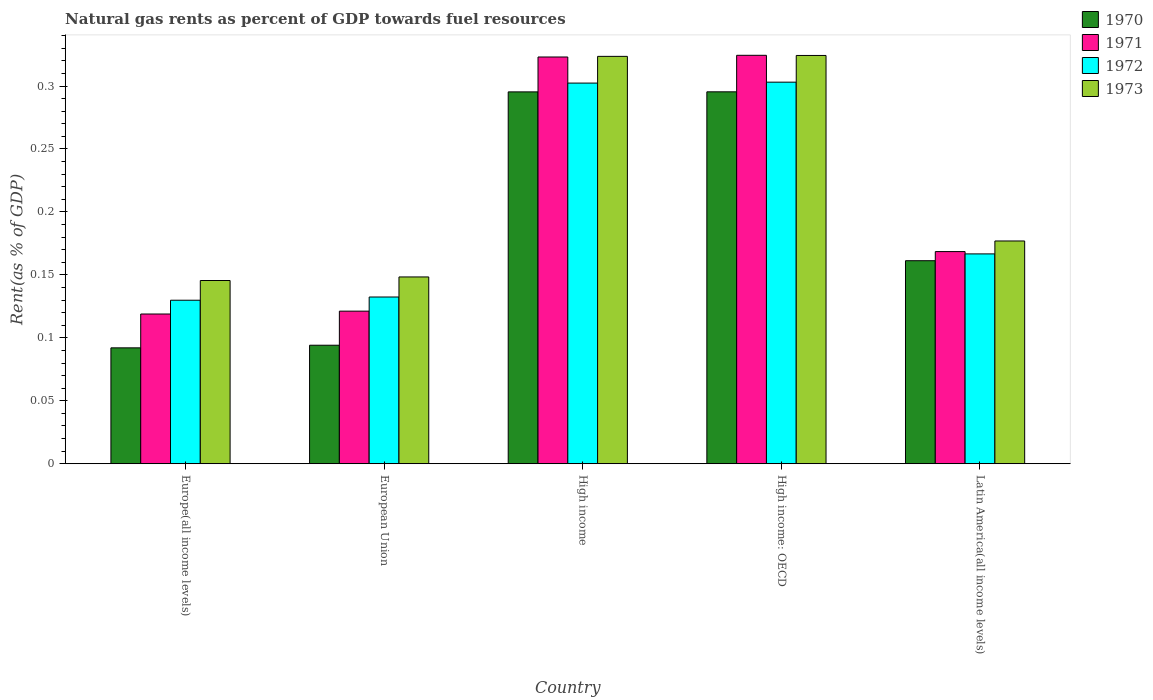How many different coloured bars are there?
Your answer should be very brief. 4. How many groups of bars are there?
Give a very brief answer. 5. Are the number of bars per tick equal to the number of legend labels?
Your answer should be compact. Yes. In how many cases, is the number of bars for a given country not equal to the number of legend labels?
Provide a short and direct response. 0. What is the matural gas rent in 1970 in Europe(all income levels)?
Provide a succinct answer. 0.09. Across all countries, what is the maximum matural gas rent in 1971?
Make the answer very short. 0.32. Across all countries, what is the minimum matural gas rent in 1970?
Make the answer very short. 0.09. In which country was the matural gas rent in 1970 maximum?
Offer a terse response. High income: OECD. In which country was the matural gas rent in 1970 minimum?
Offer a terse response. Europe(all income levels). What is the total matural gas rent in 1971 in the graph?
Ensure brevity in your answer.  1.06. What is the difference between the matural gas rent in 1973 in Europe(all income levels) and that in European Union?
Make the answer very short. -0. What is the difference between the matural gas rent in 1973 in European Union and the matural gas rent in 1970 in Europe(all income levels)?
Ensure brevity in your answer.  0.06. What is the average matural gas rent in 1972 per country?
Your answer should be very brief. 0.21. What is the difference between the matural gas rent of/in 1972 and matural gas rent of/in 1971 in European Union?
Keep it short and to the point. 0.01. In how many countries, is the matural gas rent in 1971 greater than 0.16000000000000003 %?
Give a very brief answer. 3. What is the ratio of the matural gas rent in 1970 in European Union to that in Latin America(all income levels)?
Give a very brief answer. 0.58. Is the matural gas rent in 1973 in European Union less than that in High income: OECD?
Your answer should be compact. Yes. What is the difference between the highest and the second highest matural gas rent in 1971?
Offer a terse response. 0. What is the difference between the highest and the lowest matural gas rent in 1971?
Provide a short and direct response. 0.21. In how many countries, is the matural gas rent in 1971 greater than the average matural gas rent in 1971 taken over all countries?
Offer a terse response. 2. Is it the case that in every country, the sum of the matural gas rent in 1973 and matural gas rent in 1971 is greater than the sum of matural gas rent in 1972 and matural gas rent in 1970?
Offer a terse response. No. What does the 2nd bar from the left in Europe(all income levels) represents?
Your response must be concise. 1971. Is it the case that in every country, the sum of the matural gas rent in 1973 and matural gas rent in 1971 is greater than the matural gas rent in 1972?
Your answer should be very brief. Yes. How many bars are there?
Your answer should be very brief. 20. Are all the bars in the graph horizontal?
Your answer should be very brief. No. How many countries are there in the graph?
Provide a short and direct response. 5. How many legend labels are there?
Your answer should be very brief. 4. How are the legend labels stacked?
Provide a short and direct response. Vertical. What is the title of the graph?
Your answer should be compact. Natural gas rents as percent of GDP towards fuel resources. What is the label or title of the Y-axis?
Keep it short and to the point. Rent(as % of GDP). What is the Rent(as % of GDP) in 1970 in Europe(all income levels)?
Your answer should be very brief. 0.09. What is the Rent(as % of GDP) of 1971 in Europe(all income levels)?
Your answer should be compact. 0.12. What is the Rent(as % of GDP) of 1972 in Europe(all income levels)?
Ensure brevity in your answer.  0.13. What is the Rent(as % of GDP) of 1973 in Europe(all income levels)?
Ensure brevity in your answer.  0.15. What is the Rent(as % of GDP) of 1970 in European Union?
Offer a very short reply. 0.09. What is the Rent(as % of GDP) in 1971 in European Union?
Give a very brief answer. 0.12. What is the Rent(as % of GDP) in 1972 in European Union?
Offer a terse response. 0.13. What is the Rent(as % of GDP) of 1973 in European Union?
Make the answer very short. 0.15. What is the Rent(as % of GDP) of 1970 in High income?
Your response must be concise. 0.3. What is the Rent(as % of GDP) in 1971 in High income?
Offer a terse response. 0.32. What is the Rent(as % of GDP) of 1972 in High income?
Provide a succinct answer. 0.3. What is the Rent(as % of GDP) of 1973 in High income?
Offer a terse response. 0.32. What is the Rent(as % of GDP) in 1970 in High income: OECD?
Provide a succinct answer. 0.3. What is the Rent(as % of GDP) in 1971 in High income: OECD?
Make the answer very short. 0.32. What is the Rent(as % of GDP) in 1972 in High income: OECD?
Keep it short and to the point. 0.3. What is the Rent(as % of GDP) in 1973 in High income: OECD?
Keep it short and to the point. 0.32. What is the Rent(as % of GDP) of 1970 in Latin America(all income levels)?
Offer a very short reply. 0.16. What is the Rent(as % of GDP) of 1971 in Latin America(all income levels)?
Your response must be concise. 0.17. What is the Rent(as % of GDP) of 1972 in Latin America(all income levels)?
Offer a terse response. 0.17. What is the Rent(as % of GDP) in 1973 in Latin America(all income levels)?
Give a very brief answer. 0.18. Across all countries, what is the maximum Rent(as % of GDP) of 1970?
Offer a terse response. 0.3. Across all countries, what is the maximum Rent(as % of GDP) of 1971?
Ensure brevity in your answer.  0.32. Across all countries, what is the maximum Rent(as % of GDP) in 1972?
Your response must be concise. 0.3. Across all countries, what is the maximum Rent(as % of GDP) in 1973?
Your answer should be very brief. 0.32. Across all countries, what is the minimum Rent(as % of GDP) in 1970?
Provide a succinct answer. 0.09. Across all countries, what is the minimum Rent(as % of GDP) in 1971?
Your response must be concise. 0.12. Across all countries, what is the minimum Rent(as % of GDP) in 1972?
Your answer should be very brief. 0.13. Across all countries, what is the minimum Rent(as % of GDP) in 1973?
Offer a terse response. 0.15. What is the total Rent(as % of GDP) in 1970 in the graph?
Offer a terse response. 0.94. What is the total Rent(as % of GDP) of 1971 in the graph?
Provide a short and direct response. 1.06. What is the total Rent(as % of GDP) in 1972 in the graph?
Ensure brevity in your answer.  1.03. What is the total Rent(as % of GDP) in 1973 in the graph?
Ensure brevity in your answer.  1.12. What is the difference between the Rent(as % of GDP) of 1970 in Europe(all income levels) and that in European Union?
Ensure brevity in your answer.  -0. What is the difference between the Rent(as % of GDP) in 1971 in Europe(all income levels) and that in European Union?
Provide a short and direct response. -0. What is the difference between the Rent(as % of GDP) in 1972 in Europe(all income levels) and that in European Union?
Give a very brief answer. -0. What is the difference between the Rent(as % of GDP) of 1973 in Europe(all income levels) and that in European Union?
Provide a short and direct response. -0. What is the difference between the Rent(as % of GDP) of 1970 in Europe(all income levels) and that in High income?
Keep it short and to the point. -0.2. What is the difference between the Rent(as % of GDP) in 1971 in Europe(all income levels) and that in High income?
Make the answer very short. -0.2. What is the difference between the Rent(as % of GDP) in 1972 in Europe(all income levels) and that in High income?
Make the answer very short. -0.17. What is the difference between the Rent(as % of GDP) of 1973 in Europe(all income levels) and that in High income?
Your answer should be compact. -0.18. What is the difference between the Rent(as % of GDP) in 1970 in Europe(all income levels) and that in High income: OECD?
Provide a short and direct response. -0.2. What is the difference between the Rent(as % of GDP) of 1971 in Europe(all income levels) and that in High income: OECD?
Ensure brevity in your answer.  -0.21. What is the difference between the Rent(as % of GDP) of 1972 in Europe(all income levels) and that in High income: OECD?
Ensure brevity in your answer.  -0.17. What is the difference between the Rent(as % of GDP) in 1973 in Europe(all income levels) and that in High income: OECD?
Give a very brief answer. -0.18. What is the difference between the Rent(as % of GDP) of 1970 in Europe(all income levels) and that in Latin America(all income levels)?
Your answer should be very brief. -0.07. What is the difference between the Rent(as % of GDP) of 1971 in Europe(all income levels) and that in Latin America(all income levels)?
Ensure brevity in your answer.  -0.05. What is the difference between the Rent(as % of GDP) in 1972 in Europe(all income levels) and that in Latin America(all income levels)?
Your response must be concise. -0.04. What is the difference between the Rent(as % of GDP) in 1973 in Europe(all income levels) and that in Latin America(all income levels)?
Offer a very short reply. -0.03. What is the difference between the Rent(as % of GDP) of 1970 in European Union and that in High income?
Give a very brief answer. -0.2. What is the difference between the Rent(as % of GDP) of 1971 in European Union and that in High income?
Ensure brevity in your answer.  -0.2. What is the difference between the Rent(as % of GDP) of 1972 in European Union and that in High income?
Provide a short and direct response. -0.17. What is the difference between the Rent(as % of GDP) in 1973 in European Union and that in High income?
Offer a terse response. -0.18. What is the difference between the Rent(as % of GDP) in 1970 in European Union and that in High income: OECD?
Offer a very short reply. -0.2. What is the difference between the Rent(as % of GDP) of 1971 in European Union and that in High income: OECD?
Keep it short and to the point. -0.2. What is the difference between the Rent(as % of GDP) in 1972 in European Union and that in High income: OECD?
Make the answer very short. -0.17. What is the difference between the Rent(as % of GDP) of 1973 in European Union and that in High income: OECD?
Keep it short and to the point. -0.18. What is the difference between the Rent(as % of GDP) of 1970 in European Union and that in Latin America(all income levels)?
Your response must be concise. -0.07. What is the difference between the Rent(as % of GDP) in 1971 in European Union and that in Latin America(all income levels)?
Provide a short and direct response. -0.05. What is the difference between the Rent(as % of GDP) of 1972 in European Union and that in Latin America(all income levels)?
Offer a very short reply. -0.03. What is the difference between the Rent(as % of GDP) of 1973 in European Union and that in Latin America(all income levels)?
Provide a succinct answer. -0.03. What is the difference between the Rent(as % of GDP) in 1970 in High income and that in High income: OECD?
Make the answer very short. -0. What is the difference between the Rent(as % of GDP) in 1971 in High income and that in High income: OECD?
Your response must be concise. -0. What is the difference between the Rent(as % of GDP) in 1972 in High income and that in High income: OECD?
Your answer should be very brief. -0. What is the difference between the Rent(as % of GDP) in 1973 in High income and that in High income: OECD?
Your response must be concise. -0. What is the difference between the Rent(as % of GDP) in 1970 in High income and that in Latin America(all income levels)?
Provide a succinct answer. 0.13. What is the difference between the Rent(as % of GDP) of 1971 in High income and that in Latin America(all income levels)?
Keep it short and to the point. 0.15. What is the difference between the Rent(as % of GDP) in 1972 in High income and that in Latin America(all income levels)?
Give a very brief answer. 0.14. What is the difference between the Rent(as % of GDP) in 1973 in High income and that in Latin America(all income levels)?
Provide a succinct answer. 0.15. What is the difference between the Rent(as % of GDP) in 1970 in High income: OECD and that in Latin America(all income levels)?
Your answer should be compact. 0.13. What is the difference between the Rent(as % of GDP) in 1971 in High income: OECD and that in Latin America(all income levels)?
Offer a very short reply. 0.16. What is the difference between the Rent(as % of GDP) of 1972 in High income: OECD and that in Latin America(all income levels)?
Provide a short and direct response. 0.14. What is the difference between the Rent(as % of GDP) of 1973 in High income: OECD and that in Latin America(all income levels)?
Ensure brevity in your answer.  0.15. What is the difference between the Rent(as % of GDP) in 1970 in Europe(all income levels) and the Rent(as % of GDP) in 1971 in European Union?
Make the answer very short. -0.03. What is the difference between the Rent(as % of GDP) in 1970 in Europe(all income levels) and the Rent(as % of GDP) in 1972 in European Union?
Give a very brief answer. -0.04. What is the difference between the Rent(as % of GDP) in 1970 in Europe(all income levels) and the Rent(as % of GDP) in 1973 in European Union?
Ensure brevity in your answer.  -0.06. What is the difference between the Rent(as % of GDP) in 1971 in Europe(all income levels) and the Rent(as % of GDP) in 1972 in European Union?
Give a very brief answer. -0.01. What is the difference between the Rent(as % of GDP) in 1971 in Europe(all income levels) and the Rent(as % of GDP) in 1973 in European Union?
Your answer should be very brief. -0.03. What is the difference between the Rent(as % of GDP) in 1972 in Europe(all income levels) and the Rent(as % of GDP) in 1973 in European Union?
Your answer should be very brief. -0.02. What is the difference between the Rent(as % of GDP) of 1970 in Europe(all income levels) and the Rent(as % of GDP) of 1971 in High income?
Make the answer very short. -0.23. What is the difference between the Rent(as % of GDP) of 1970 in Europe(all income levels) and the Rent(as % of GDP) of 1972 in High income?
Ensure brevity in your answer.  -0.21. What is the difference between the Rent(as % of GDP) of 1970 in Europe(all income levels) and the Rent(as % of GDP) of 1973 in High income?
Your answer should be very brief. -0.23. What is the difference between the Rent(as % of GDP) of 1971 in Europe(all income levels) and the Rent(as % of GDP) of 1972 in High income?
Offer a very short reply. -0.18. What is the difference between the Rent(as % of GDP) in 1971 in Europe(all income levels) and the Rent(as % of GDP) in 1973 in High income?
Ensure brevity in your answer.  -0.2. What is the difference between the Rent(as % of GDP) in 1972 in Europe(all income levels) and the Rent(as % of GDP) in 1973 in High income?
Offer a very short reply. -0.19. What is the difference between the Rent(as % of GDP) of 1970 in Europe(all income levels) and the Rent(as % of GDP) of 1971 in High income: OECD?
Make the answer very short. -0.23. What is the difference between the Rent(as % of GDP) of 1970 in Europe(all income levels) and the Rent(as % of GDP) of 1972 in High income: OECD?
Your response must be concise. -0.21. What is the difference between the Rent(as % of GDP) in 1970 in Europe(all income levels) and the Rent(as % of GDP) in 1973 in High income: OECD?
Keep it short and to the point. -0.23. What is the difference between the Rent(as % of GDP) of 1971 in Europe(all income levels) and the Rent(as % of GDP) of 1972 in High income: OECD?
Provide a succinct answer. -0.18. What is the difference between the Rent(as % of GDP) of 1971 in Europe(all income levels) and the Rent(as % of GDP) of 1973 in High income: OECD?
Provide a short and direct response. -0.21. What is the difference between the Rent(as % of GDP) of 1972 in Europe(all income levels) and the Rent(as % of GDP) of 1973 in High income: OECD?
Ensure brevity in your answer.  -0.19. What is the difference between the Rent(as % of GDP) of 1970 in Europe(all income levels) and the Rent(as % of GDP) of 1971 in Latin America(all income levels)?
Make the answer very short. -0.08. What is the difference between the Rent(as % of GDP) of 1970 in Europe(all income levels) and the Rent(as % of GDP) of 1972 in Latin America(all income levels)?
Your answer should be very brief. -0.07. What is the difference between the Rent(as % of GDP) in 1970 in Europe(all income levels) and the Rent(as % of GDP) in 1973 in Latin America(all income levels)?
Offer a very short reply. -0.08. What is the difference between the Rent(as % of GDP) in 1971 in Europe(all income levels) and the Rent(as % of GDP) in 1972 in Latin America(all income levels)?
Offer a very short reply. -0.05. What is the difference between the Rent(as % of GDP) of 1971 in Europe(all income levels) and the Rent(as % of GDP) of 1973 in Latin America(all income levels)?
Your answer should be very brief. -0.06. What is the difference between the Rent(as % of GDP) in 1972 in Europe(all income levels) and the Rent(as % of GDP) in 1973 in Latin America(all income levels)?
Ensure brevity in your answer.  -0.05. What is the difference between the Rent(as % of GDP) in 1970 in European Union and the Rent(as % of GDP) in 1971 in High income?
Provide a succinct answer. -0.23. What is the difference between the Rent(as % of GDP) of 1970 in European Union and the Rent(as % of GDP) of 1972 in High income?
Keep it short and to the point. -0.21. What is the difference between the Rent(as % of GDP) of 1970 in European Union and the Rent(as % of GDP) of 1973 in High income?
Your response must be concise. -0.23. What is the difference between the Rent(as % of GDP) in 1971 in European Union and the Rent(as % of GDP) in 1972 in High income?
Make the answer very short. -0.18. What is the difference between the Rent(as % of GDP) of 1971 in European Union and the Rent(as % of GDP) of 1973 in High income?
Offer a terse response. -0.2. What is the difference between the Rent(as % of GDP) of 1972 in European Union and the Rent(as % of GDP) of 1973 in High income?
Offer a very short reply. -0.19. What is the difference between the Rent(as % of GDP) of 1970 in European Union and the Rent(as % of GDP) of 1971 in High income: OECD?
Provide a short and direct response. -0.23. What is the difference between the Rent(as % of GDP) in 1970 in European Union and the Rent(as % of GDP) in 1972 in High income: OECD?
Offer a terse response. -0.21. What is the difference between the Rent(as % of GDP) of 1970 in European Union and the Rent(as % of GDP) of 1973 in High income: OECD?
Your answer should be very brief. -0.23. What is the difference between the Rent(as % of GDP) of 1971 in European Union and the Rent(as % of GDP) of 1972 in High income: OECD?
Ensure brevity in your answer.  -0.18. What is the difference between the Rent(as % of GDP) in 1971 in European Union and the Rent(as % of GDP) in 1973 in High income: OECD?
Keep it short and to the point. -0.2. What is the difference between the Rent(as % of GDP) in 1972 in European Union and the Rent(as % of GDP) in 1973 in High income: OECD?
Offer a very short reply. -0.19. What is the difference between the Rent(as % of GDP) of 1970 in European Union and the Rent(as % of GDP) of 1971 in Latin America(all income levels)?
Your answer should be compact. -0.07. What is the difference between the Rent(as % of GDP) in 1970 in European Union and the Rent(as % of GDP) in 1972 in Latin America(all income levels)?
Provide a succinct answer. -0.07. What is the difference between the Rent(as % of GDP) of 1970 in European Union and the Rent(as % of GDP) of 1973 in Latin America(all income levels)?
Ensure brevity in your answer.  -0.08. What is the difference between the Rent(as % of GDP) in 1971 in European Union and the Rent(as % of GDP) in 1972 in Latin America(all income levels)?
Make the answer very short. -0.05. What is the difference between the Rent(as % of GDP) in 1971 in European Union and the Rent(as % of GDP) in 1973 in Latin America(all income levels)?
Give a very brief answer. -0.06. What is the difference between the Rent(as % of GDP) in 1972 in European Union and the Rent(as % of GDP) in 1973 in Latin America(all income levels)?
Provide a short and direct response. -0.04. What is the difference between the Rent(as % of GDP) of 1970 in High income and the Rent(as % of GDP) of 1971 in High income: OECD?
Offer a terse response. -0.03. What is the difference between the Rent(as % of GDP) in 1970 in High income and the Rent(as % of GDP) in 1972 in High income: OECD?
Your response must be concise. -0.01. What is the difference between the Rent(as % of GDP) in 1970 in High income and the Rent(as % of GDP) in 1973 in High income: OECD?
Your answer should be compact. -0.03. What is the difference between the Rent(as % of GDP) of 1971 in High income and the Rent(as % of GDP) of 1973 in High income: OECD?
Give a very brief answer. -0. What is the difference between the Rent(as % of GDP) in 1972 in High income and the Rent(as % of GDP) in 1973 in High income: OECD?
Make the answer very short. -0.02. What is the difference between the Rent(as % of GDP) in 1970 in High income and the Rent(as % of GDP) in 1971 in Latin America(all income levels)?
Provide a succinct answer. 0.13. What is the difference between the Rent(as % of GDP) of 1970 in High income and the Rent(as % of GDP) of 1972 in Latin America(all income levels)?
Offer a very short reply. 0.13. What is the difference between the Rent(as % of GDP) of 1970 in High income and the Rent(as % of GDP) of 1973 in Latin America(all income levels)?
Keep it short and to the point. 0.12. What is the difference between the Rent(as % of GDP) in 1971 in High income and the Rent(as % of GDP) in 1972 in Latin America(all income levels)?
Your answer should be compact. 0.16. What is the difference between the Rent(as % of GDP) in 1971 in High income and the Rent(as % of GDP) in 1973 in Latin America(all income levels)?
Give a very brief answer. 0.15. What is the difference between the Rent(as % of GDP) of 1972 in High income and the Rent(as % of GDP) of 1973 in Latin America(all income levels)?
Your answer should be compact. 0.13. What is the difference between the Rent(as % of GDP) in 1970 in High income: OECD and the Rent(as % of GDP) in 1971 in Latin America(all income levels)?
Your answer should be compact. 0.13. What is the difference between the Rent(as % of GDP) in 1970 in High income: OECD and the Rent(as % of GDP) in 1972 in Latin America(all income levels)?
Keep it short and to the point. 0.13. What is the difference between the Rent(as % of GDP) in 1970 in High income: OECD and the Rent(as % of GDP) in 1973 in Latin America(all income levels)?
Provide a succinct answer. 0.12. What is the difference between the Rent(as % of GDP) in 1971 in High income: OECD and the Rent(as % of GDP) in 1972 in Latin America(all income levels)?
Your answer should be very brief. 0.16. What is the difference between the Rent(as % of GDP) of 1971 in High income: OECD and the Rent(as % of GDP) of 1973 in Latin America(all income levels)?
Provide a short and direct response. 0.15. What is the difference between the Rent(as % of GDP) of 1972 in High income: OECD and the Rent(as % of GDP) of 1973 in Latin America(all income levels)?
Offer a very short reply. 0.13. What is the average Rent(as % of GDP) of 1970 per country?
Offer a very short reply. 0.19. What is the average Rent(as % of GDP) of 1971 per country?
Give a very brief answer. 0.21. What is the average Rent(as % of GDP) of 1972 per country?
Make the answer very short. 0.21. What is the average Rent(as % of GDP) in 1973 per country?
Make the answer very short. 0.22. What is the difference between the Rent(as % of GDP) of 1970 and Rent(as % of GDP) of 1971 in Europe(all income levels)?
Keep it short and to the point. -0.03. What is the difference between the Rent(as % of GDP) in 1970 and Rent(as % of GDP) in 1972 in Europe(all income levels)?
Offer a very short reply. -0.04. What is the difference between the Rent(as % of GDP) of 1970 and Rent(as % of GDP) of 1973 in Europe(all income levels)?
Offer a terse response. -0.05. What is the difference between the Rent(as % of GDP) of 1971 and Rent(as % of GDP) of 1972 in Europe(all income levels)?
Your answer should be very brief. -0.01. What is the difference between the Rent(as % of GDP) in 1971 and Rent(as % of GDP) in 1973 in Europe(all income levels)?
Provide a succinct answer. -0.03. What is the difference between the Rent(as % of GDP) in 1972 and Rent(as % of GDP) in 1973 in Europe(all income levels)?
Provide a succinct answer. -0.02. What is the difference between the Rent(as % of GDP) in 1970 and Rent(as % of GDP) in 1971 in European Union?
Your answer should be very brief. -0.03. What is the difference between the Rent(as % of GDP) in 1970 and Rent(as % of GDP) in 1972 in European Union?
Your answer should be compact. -0.04. What is the difference between the Rent(as % of GDP) of 1970 and Rent(as % of GDP) of 1973 in European Union?
Provide a short and direct response. -0.05. What is the difference between the Rent(as % of GDP) of 1971 and Rent(as % of GDP) of 1972 in European Union?
Provide a short and direct response. -0.01. What is the difference between the Rent(as % of GDP) of 1971 and Rent(as % of GDP) of 1973 in European Union?
Ensure brevity in your answer.  -0.03. What is the difference between the Rent(as % of GDP) in 1972 and Rent(as % of GDP) in 1973 in European Union?
Offer a terse response. -0.02. What is the difference between the Rent(as % of GDP) of 1970 and Rent(as % of GDP) of 1971 in High income?
Your answer should be compact. -0.03. What is the difference between the Rent(as % of GDP) of 1970 and Rent(as % of GDP) of 1972 in High income?
Your answer should be compact. -0.01. What is the difference between the Rent(as % of GDP) of 1970 and Rent(as % of GDP) of 1973 in High income?
Keep it short and to the point. -0.03. What is the difference between the Rent(as % of GDP) in 1971 and Rent(as % of GDP) in 1972 in High income?
Provide a short and direct response. 0.02. What is the difference between the Rent(as % of GDP) of 1971 and Rent(as % of GDP) of 1973 in High income?
Provide a short and direct response. -0. What is the difference between the Rent(as % of GDP) of 1972 and Rent(as % of GDP) of 1973 in High income?
Make the answer very short. -0.02. What is the difference between the Rent(as % of GDP) in 1970 and Rent(as % of GDP) in 1971 in High income: OECD?
Keep it short and to the point. -0.03. What is the difference between the Rent(as % of GDP) in 1970 and Rent(as % of GDP) in 1972 in High income: OECD?
Your answer should be compact. -0.01. What is the difference between the Rent(as % of GDP) of 1970 and Rent(as % of GDP) of 1973 in High income: OECD?
Your answer should be very brief. -0.03. What is the difference between the Rent(as % of GDP) in 1971 and Rent(as % of GDP) in 1972 in High income: OECD?
Offer a very short reply. 0.02. What is the difference between the Rent(as % of GDP) of 1972 and Rent(as % of GDP) of 1973 in High income: OECD?
Offer a very short reply. -0.02. What is the difference between the Rent(as % of GDP) of 1970 and Rent(as % of GDP) of 1971 in Latin America(all income levels)?
Provide a succinct answer. -0.01. What is the difference between the Rent(as % of GDP) in 1970 and Rent(as % of GDP) in 1972 in Latin America(all income levels)?
Offer a very short reply. -0.01. What is the difference between the Rent(as % of GDP) in 1970 and Rent(as % of GDP) in 1973 in Latin America(all income levels)?
Give a very brief answer. -0.02. What is the difference between the Rent(as % of GDP) in 1971 and Rent(as % of GDP) in 1972 in Latin America(all income levels)?
Make the answer very short. 0. What is the difference between the Rent(as % of GDP) in 1971 and Rent(as % of GDP) in 1973 in Latin America(all income levels)?
Give a very brief answer. -0.01. What is the difference between the Rent(as % of GDP) of 1972 and Rent(as % of GDP) of 1973 in Latin America(all income levels)?
Make the answer very short. -0.01. What is the ratio of the Rent(as % of GDP) of 1970 in Europe(all income levels) to that in European Union?
Ensure brevity in your answer.  0.98. What is the ratio of the Rent(as % of GDP) in 1971 in Europe(all income levels) to that in European Union?
Your answer should be compact. 0.98. What is the ratio of the Rent(as % of GDP) in 1972 in Europe(all income levels) to that in European Union?
Ensure brevity in your answer.  0.98. What is the ratio of the Rent(as % of GDP) of 1973 in Europe(all income levels) to that in European Union?
Provide a short and direct response. 0.98. What is the ratio of the Rent(as % of GDP) in 1970 in Europe(all income levels) to that in High income?
Your answer should be compact. 0.31. What is the ratio of the Rent(as % of GDP) in 1971 in Europe(all income levels) to that in High income?
Your answer should be very brief. 0.37. What is the ratio of the Rent(as % of GDP) of 1972 in Europe(all income levels) to that in High income?
Provide a short and direct response. 0.43. What is the ratio of the Rent(as % of GDP) of 1973 in Europe(all income levels) to that in High income?
Give a very brief answer. 0.45. What is the ratio of the Rent(as % of GDP) in 1970 in Europe(all income levels) to that in High income: OECD?
Your answer should be very brief. 0.31. What is the ratio of the Rent(as % of GDP) of 1971 in Europe(all income levels) to that in High income: OECD?
Ensure brevity in your answer.  0.37. What is the ratio of the Rent(as % of GDP) of 1972 in Europe(all income levels) to that in High income: OECD?
Ensure brevity in your answer.  0.43. What is the ratio of the Rent(as % of GDP) of 1973 in Europe(all income levels) to that in High income: OECD?
Offer a terse response. 0.45. What is the ratio of the Rent(as % of GDP) in 1970 in Europe(all income levels) to that in Latin America(all income levels)?
Offer a very short reply. 0.57. What is the ratio of the Rent(as % of GDP) of 1971 in Europe(all income levels) to that in Latin America(all income levels)?
Your answer should be compact. 0.71. What is the ratio of the Rent(as % of GDP) of 1972 in Europe(all income levels) to that in Latin America(all income levels)?
Keep it short and to the point. 0.78. What is the ratio of the Rent(as % of GDP) in 1973 in Europe(all income levels) to that in Latin America(all income levels)?
Your response must be concise. 0.82. What is the ratio of the Rent(as % of GDP) of 1970 in European Union to that in High income?
Provide a short and direct response. 0.32. What is the ratio of the Rent(as % of GDP) in 1971 in European Union to that in High income?
Offer a terse response. 0.38. What is the ratio of the Rent(as % of GDP) in 1972 in European Union to that in High income?
Your answer should be compact. 0.44. What is the ratio of the Rent(as % of GDP) in 1973 in European Union to that in High income?
Your answer should be very brief. 0.46. What is the ratio of the Rent(as % of GDP) in 1970 in European Union to that in High income: OECD?
Ensure brevity in your answer.  0.32. What is the ratio of the Rent(as % of GDP) in 1971 in European Union to that in High income: OECD?
Your answer should be very brief. 0.37. What is the ratio of the Rent(as % of GDP) of 1972 in European Union to that in High income: OECD?
Your response must be concise. 0.44. What is the ratio of the Rent(as % of GDP) of 1973 in European Union to that in High income: OECD?
Ensure brevity in your answer.  0.46. What is the ratio of the Rent(as % of GDP) in 1970 in European Union to that in Latin America(all income levels)?
Provide a succinct answer. 0.58. What is the ratio of the Rent(as % of GDP) of 1971 in European Union to that in Latin America(all income levels)?
Provide a short and direct response. 0.72. What is the ratio of the Rent(as % of GDP) in 1972 in European Union to that in Latin America(all income levels)?
Your answer should be very brief. 0.79. What is the ratio of the Rent(as % of GDP) in 1973 in European Union to that in Latin America(all income levels)?
Your answer should be compact. 0.84. What is the ratio of the Rent(as % of GDP) in 1970 in High income to that in Latin America(all income levels)?
Provide a short and direct response. 1.83. What is the ratio of the Rent(as % of GDP) of 1971 in High income to that in Latin America(all income levels)?
Keep it short and to the point. 1.92. What is the ratio of the Rent(as % of GDP) of 1972 in High income to that in Latin America(all income levels)?
Your answer should be compact. 1.81. What is the ratio of the Rent(as % of GDP) of 1973 in High income to that in Latin America(all income levels)?
Your response must be concise. 1.83. What is the ratio of the Rent(as % of GDP) of 1970 in High income: OECD to that in Latin America(all income levels)?
Offer a terse response. 1.83. What is the ratio of the Rent(as % of GDP) of 1971 in High income: OECD to that in Latin America(all income levels)?
Keep it short and to the point. 1.93. What is the ratio of the Rent(as % of GDP) in 1972 in High income: OECD to that in Latin America(all income levels)?
Provide a succinct answer. 1.82. What is the ratio of the Rent(as % of GDP) of 1973 in High income: OECD to that in Latin America(all income levels)?
Provide a short and direct response. 1.83. What is the difference between the highest and the second highest Rent(as % of GDP) in 1970?
Provide a succinct answer. 0. What is the difference between the highest and the second highest Rent(as % of GDP) in 1971?
Make the answer very short. 0. What is the difference between the highest and the second highest Rent(as % of GDP) of 1972?
Provide a succinct answer. 0. What is the difference between the highest and the second highest Rent(as % of GDP) of 1973?
Your response must be concise. 0. What is the difference between the highest and the lowest Rent(as % of GDP) in 1970?
Your response must be concise. 0.2. What is the difference between the highest and the lowest Rent(as % of GDP) of 1971?
Your response must be concise. 0.21. What is the difference between the highest and the lowest Rent(as % of GDP) of 1972?
Ensure brevity in your answer.  0.17. What is the difference between the highest and the lowest Rent(as % of GDP) of 1973?
Ensure brevity in your answer.  0.18. 